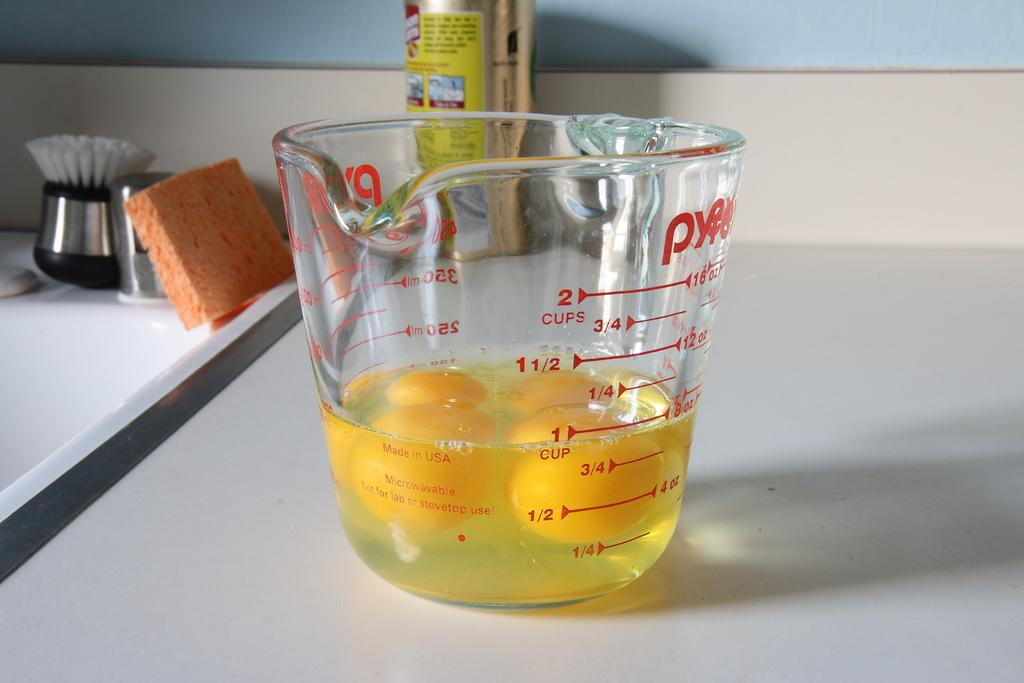Provide a one-sentence caption for the provided image. a measuring cup with 4 egg yolks on the counter. 